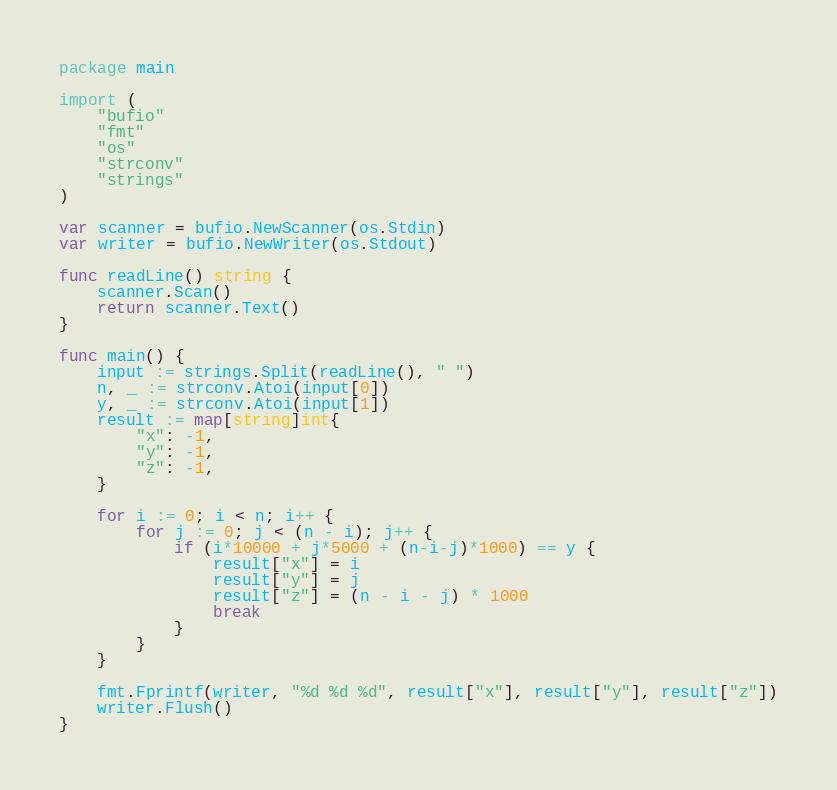Convert code to text. <code><loc_0><loc_0><loc_500><loc_500><_Go_>package main

import (
	"bufio"
	"fmt"
	"os"
	"strconv"
	"strings"
)

var scanner = bufio.NewScanner(os.Stdin)
var writer = bufio.NewWriter(os.Stdout)

func readLine() string {
	scanner.Scan()
	return scanner.Text()
}

func main() {
	input := strings.Split(readLine(), " ")
	n, _ := strconv.Atoi(input[0])
	y, _ := strconv.Atoi(input[1])
	result := map[string]int{
		"x": -1,
		"y": -1,
		"z": -1,
	}

	for i := 0; i < n; i++ {
		for j := 0; j < (n - i); j++ {
			if (i*10000 + j*5000 + (n-i-j)*1000) == y {
				result["x"] = i
				result["y"] = j
				result["z"] = (n - i - j) * 1000
				break
			}
		}
	}

	fmt.Fprintf(writer, "%d %d %d", result["x"], result["y"], result["z"])
	writer.Flush()
}
</code> 